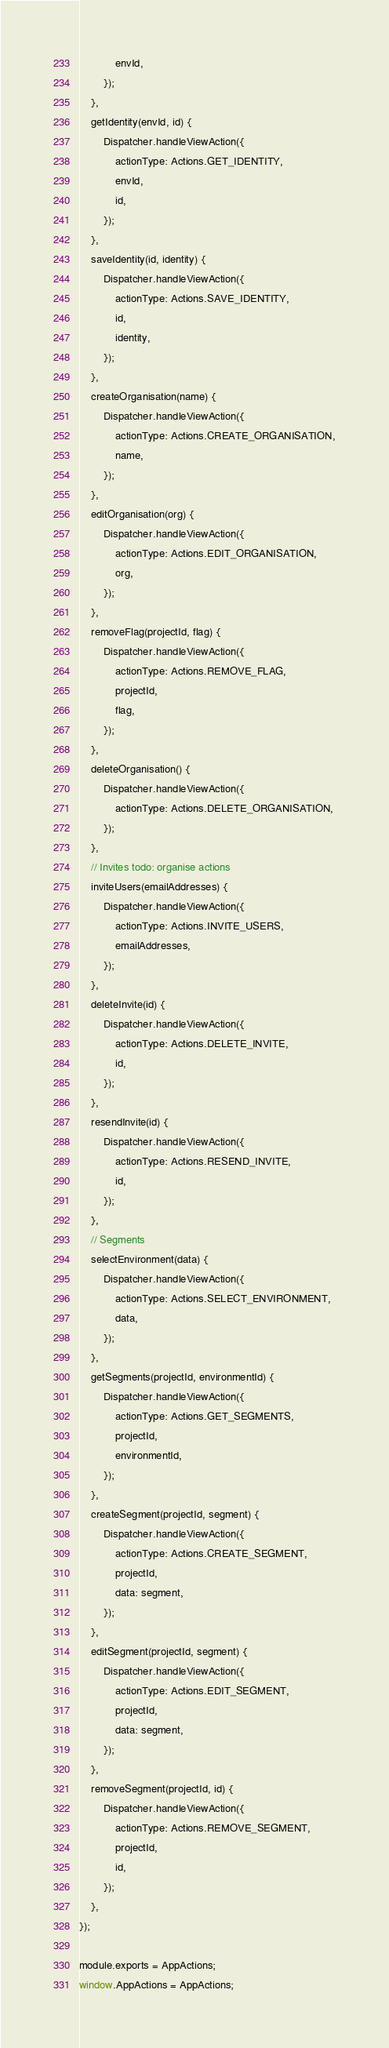<code> <loc_0><loc_0><loc_500><loc_500><_JavaScript_>            envId,
        });
    },
    getIdentity(envId, id) {
        Dispatcher.handleViewAction({
            actionType: Actions.GET_IDENTITY,
            envId,
            id,
        });
    },
    saveIdentity(id, identity) {
        Dispatcher.handleViewAction({
            actionType: Actions.SAVE_IDENTITY,
            id,
            identity,
        });
    },
    createOrganisation(name) {
        Dispatcher.handleViewAction({
            actionType: Actions.CREATE_ORGANISATION,
            name,
        });
    },
    editOrganisation(org) {
        Dispatcher.handleViewAction({
            actionType: Actions.EDIT_ORGANISATION,
            org,
        });
    },
    removeFlag(projectId, flag) {
        Dispatcher.handleViewAction({
            actionType: Actions.REMOVE_FLAG,
            projectId,
            flag,
        });
    },
    deleteOrganisation() {
        Dispatcher.handleViewAction({
            actionType: Actions.DELETE_ORGANISATION,
        });
    },
    // Invites todo: organise actions
    inviteUsers(emailAddresses) {
        Dispatcher.handleViewAction({
            actionType: Actions.INVITE_USERS,
            emailAddresses,
        });
    },
    deleteInvite(id) {
        Dispatcher.handleViewAction({
            actionType: Actions.DELETE_INVITE,
            id,
        });
    },
    resendInvite(id) {
        Dispatcher.handleViewAction({
            actionType: Actions.RESEND_INVITE,
            id,
        });
    },
    // Segments
    selectEnvironment(data) {
        Dispatcher.handleViewAction({
            actionType: Actions.SELECT_ENVIRONMENT,
            data,
        });
    },
    getSegments(projectId, environmentId) {
        Dispatcher.handleViewAction({
            actionType: Actions.GET_SEGMENTS,
            projectId,
            environmentId,
        });
    },
    createSegment(projectId, segment) {
        Dispatcher.handleViewAction({
            actionType: Actions.CREATE_SEGMENT,
            projectId,
            data: segment,
        });
    },
    editSegment(projectId, segment) {
        Dispatcher.handleViewAction({
            actionType: Actions.EDIT_SEGMENT,
            projectId,
            data: segment,
        });
    },
    removeSegment(projectId, id) {
        Dispatcher.handleViewAction({
            actionType: Actions.REMOVE_SEGMENT,
            projectId,
            id,
        });
    },
});

module.exports = AppActions;
window.AppActions = AppActions;
</code> 